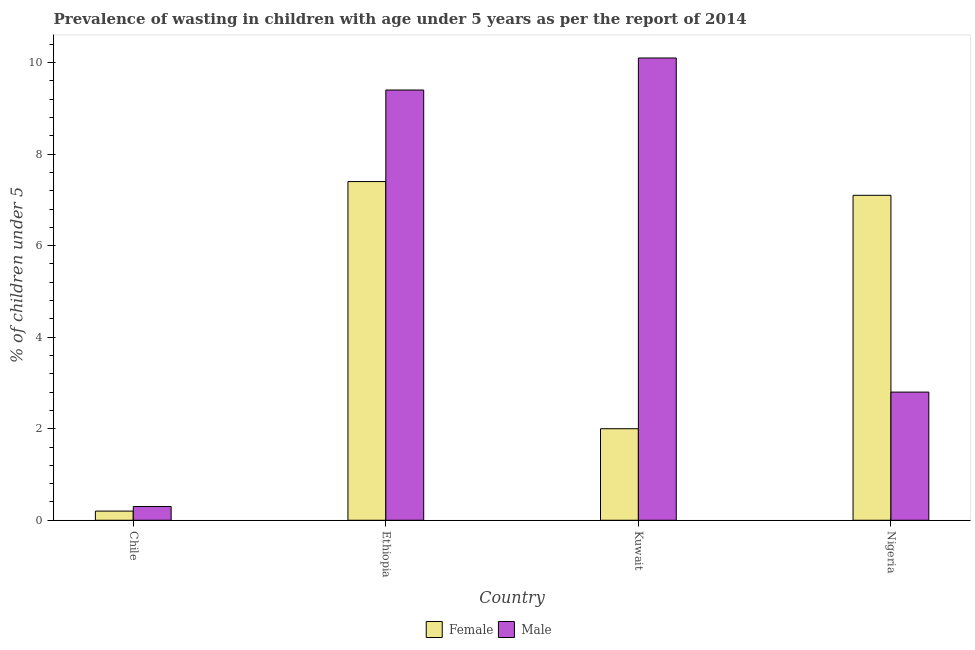How many groups of bars are there?
Provide a short and direct response. 4. Are the number of bars per tick equal to the number of legend labels?
Your response must be concise. Yes. Are the number of bars on each tick of the X-axis equal?
Offer a very short reply. Yes. How many bars are there on the 4th tick from the left?
Your response must be concise. 2. How many bars are there on the 3rd tick from the right?
Your response must be concise. 2. What is the label of the 1st group of bars from the left?
Make the answer very short. Chile. In how many cases, is the number of bars for a given country not equal to the number of legend labels?
Provide a short and direct response. 0. What is the percentage of undernourished female children in Chile?
Provide a short and direct response. 0.2. Across all countries, what is the maximum percentage of undernourished female children?
Ensure brevity in your answer.  7.4. Across all countries, what is the minimum percentage of undernourished female children?
Offer a terse response. 0.2. In which country was the percentage of undernourished male children maximum?
Your response must be concise. Kuwait. What is the total percentage of undernourished male children in the graph?
Keep it short and to the point. 22.6. What is the difference between the percentage of undernourished male children in Ethiopia and that in Kuwait?
Provide a short and direct response. -0.7. What is the difference between the percentage of undernourished male children in Chile and the percentage of undernourished female children in Nigeria?
Make the answer very short. -6.8. What is the average percentage of undernourished female children per country?
Make the answer very short. 4.18. What is the difference between the percentage of undernourished female children and percentage of undernourished male children in Chile?
Your answer should be very brief. -0.1. What is the ratio of the percentage of undernourished female children in Ethiopia to that in Kuwait?
Your response must be concise. 3.7. Is the percentage of undernourished female children in Ethiopia less than that in Kuwait?
Your answer should be compact. No. Is the difference between the percentage of undernourished female children in Chile and Ethiopia greater than the difference between the percentage of undernourished male children in Chile and Ethiopia?
Keep it short and to the point. Yes. What is the difference between the highest and the second highest percentage of undernourished male children?
Ensure brevity in your answer.  0.7. What is the difference between the highest and the lowest percentage of undernourished female children?
Provide a succinct answer. 7.2. In how many countries, is the percentage of undernourished male children greater than the average percentage of undernourished male children taken over all countries?
Offer a very short reply. 2. What does the 2nd bar from the left in Chile represents?
Your answer should be very brief. Male. How many bars are there?
Make the answer very short. 8. How many countries are there in the graph?
Offer a terse response. 4. Are the values on the major ticks of Y-axis written in scientific E-notation?
Make the answer very short. No. Where does the legend appear in the graph?
Your response must be concise. Bottom center. How many legend labels are there?
Keep it short and to the point. 2. How are the legend labels stacked?
Make the answer very short. Horizontal. What is the title of the graph?
Ensure brevity in your answer.  Prevalence of wasting in children with age under 5 years as per the report of 2014. What is the label or title of the X-axis?
Offer a terse response. Country. What is the label or title of the Y-axis?
Give a very brief answer.  % of children under 5. What is the  % of children under 5 in Female in Chile?
Give a very brief answer. 0.2. What is the  % of children under 5 of Male in Chile?
Offer a very short reply. 0.3. What is the  % of children under 5 in Female in Ethiopia?
Offer a terse response. 7.4. What is the  % of children under 5 of Male in Ethiopia?
Provide a short and direct response. 9.4. What is the  % of children under 5 in Male in Kuwait?
Offer a terse response. 10.1. What is the  % of children under 5 in Female in Nigeria?
Offer a very short reply. 7.1. What is the  % of children under 5 of Male in Nigeria?
Offer a very short reply. 2.8. Across all countries, what is the maximum  % of children under 5 in Female?
Offer a very short reply. 7.4. Across all countries, what is the maximum  % of children under 5 of Male?
Provide a short and direct response. 10.1. Across all countries, what is the minimum  % of children under 5 in Female?
Offer a terse response. 0.2. Across all countries, what is the minimum  % of children under 5 in Male?
Provide a succinct answer. 0.3. What is the total  % of children under 5 in Male in the graph?
Offer a very short reply. 22.6. What is the difference between the  % of children under 5 in Female in Chile and that in Kuwait?
Give a very brief answer. -1.8. What is the difference between the  % of children under 5 in Male in Ethiopia and that in Kuwait?
Offer a very short reply. -0.7. What is the difference between the  % of children under 5 of Female in Kuwait and that in Nigeria?
Make the answer very short. -5.1. What is the difference between the  % of children under 5 of Female in Chile and the  % of children under 5 of Male in Ethiopia?
Your response must be concise. -9.2. What is the difference between the  % of children under 5 in Female in Chile and the  % of children under 5 in Male in Kuwait?
Ensure brevity in your answer.  -9.9. What is the difference between the  % of children under 5 of Female in Ethiopia and the  % of children under 5 of Male in Nigeria?
Make the answer very short. 4.6. What is the average  % of children under 5 in Female per country?
Offer a terse response. 4.17. What is the average  % of children under 5 of Male per country?
Give a very brief answer. 5.65. What is the difference between the  % of children under 5 in Female and  % of children under 5 in Male in Ethiopia?
Offer a very short reply. -2. What is the difference between the  % of children under 5 of Female and  % of children under 5 of Male in Kuwait?
Offer a very short reply. -8.1. What is the difference between the  % of children under 5 of Female and  % of children under 5 of Male in Nigeria?
Ensure brevity in your answer.  4.3. What is the ratio of the  % of children under 5 of Female in Chile to that in Ethiopia?
Offer a terse response. 0.03. What is the ratio of the  % of children under 5 in Male in Chile to that in Ethiopia?
Keep it short and to the point. 0.03. What is the ratio of the  % of children under 5 of Male in Chile to that in Kuwait?
Provide a short and direct response. 0.03. What is the ratio of the  % of children under 5 in Female in Chile to that in Nigeria?
Provide a short and direct response. 0.03. What is the ratio of the  % of children under 5 of Male in Chile to that in Nigeria?
Ensure brevity in your answer.  0.11. What is the ratio of the  % of children under 5 in Male in Ethiopia to that in Kuwait?
Offer a terse response. 0.93. What is the ratio of the  % of children under 5 in Female in Ethiopia to that in Nigeria?
Provide a succinct answer. 1.04. What is the ratio of the  % of children under 5 of Male in Ethiopia to that in Nigeria?
Offer a terse response. 3.36. What is the ratio of the  % of children under 5 of Female in Kuwait to that in Nigeria?
Give a very brief answer. 0.28. What is the ratio of the  % of children under 5 of Male in Kuwait to that in Nigeria?
Provide a short and direct response. 3.61. What is the difference between the highest and the second highest  % of children under 5 in Female?
Give a very brief answer. 0.3. What is the difference between the highest and the second highest  % of children under 5 of Male?
Offer a terse response. 0.7. What is the difference between the highest and the lowest  % of children under 5 of Female?
Make the answer very short. 7.2. What is the difference between the highest and the lowest  % of children under 5 in Male?
Give a very brief answer. 9.8. 